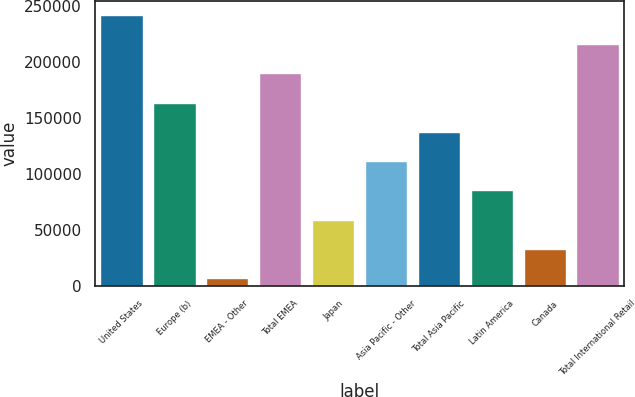Convert chart to OTSL. <chart><loc_0><loc_0><loc_500><loc_500><bar_chart><fcel>United States<fcel>Europe (b)<fcel>EMEA - Other<fcel>Total EMEA<fcel>Japan<fcel>Asia Pacific - Other<fcel>Total Asia Pacific<fcel>Latin America<fcel>Canada<fcel>Total International Retail<nl><fcel>241882<fcel>163532<fcel>6832<fcel>189649<fcel>59065.4<fcel>111299<fcel>137416<fcel>85182.1<fcel>32948.7<fcel>215766<nl></chart> 